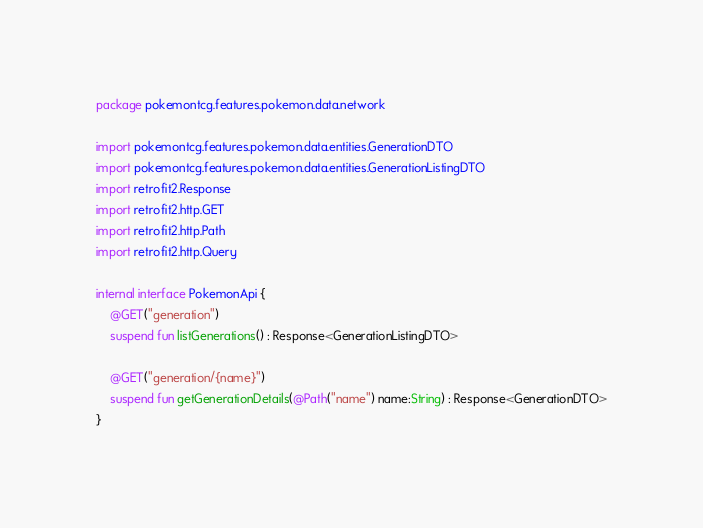Convert code to text. <code><loc_0><loc_0><loc_500><loc_500><_Kotlin_>package pokemontcg.features.pokemon.data.network

import pokemontcg.features.pokemon.data.entities.GenerationDTO
import pokemontcg.features.pokemon.data.entities.GenerationListingDTO
import retrofit2.Response
import retrofit2.http.GET
import retrofit2.http.Path
import retrofit2.http.Query

internal interface PokemonApi {
    @GET("generation")
    suspend fun listGenerations() : Response<GenerationListingDTO>

    @GET("generation/{name}")
    suspend fun getGenerationDetails(@Path("name") name:String) : Response<GenerationDTO>
}</code> 